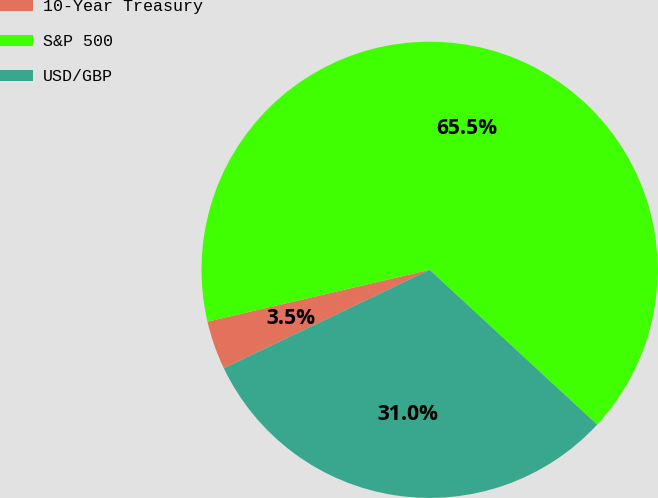Convert chart. <chart><loc_0><loc_0><loc_500><loc_500><pie_chart><fcel>10-Year Treasury<fcel>S&P 500<fcel>USD/GBP<nl><fcel>3.45%<fcel>65.52%<fcel>31.03%<nl></chart> 